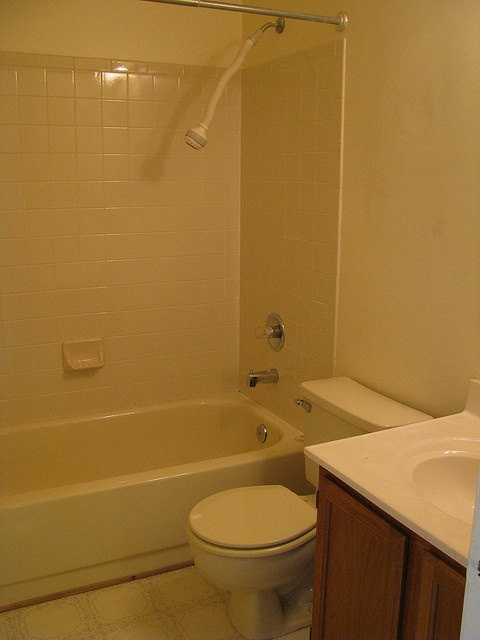Describe the objects in this image and their specific colors. I can see toilet in olive and maroon tones and sink in olive, tan, and darkgray tones in this image. 